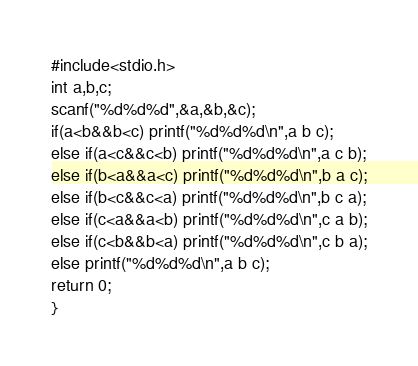<code> <loc_0><loc_0><loc_500><loc_500><_C_>#include<stdio.h>
int a,b,c;
scanf("%d%d%d",&a,&b,&c);
if(a<b&&b<c) printf("%d%d%d\n",a b c);
else if(a<c&&c<b) printf("%d%d%d\n",a c b);
else if(b<a&&a<c) printf("%d%d%d\n",b a c);
else if(b<c&&c<a) printf("%d%d%d\n",b c a);
else if(c<a&&a<b) printf("%d%d%d\n",c a b);
else if(c<b&&b<a) printf("%d%d%d\n",c b a);
else printf("%d%d%d\n",a b c);
return 0;
}</code> 